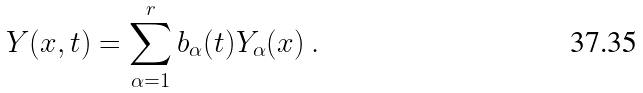Convert formula to latex. <formula><loc_0><loc_0><loc_500><loc_500>Y ( x , t ) = \sum _ { \alpha = 1 } ^ { r } b _ { \alpha } ( t ) Y _ { \alpha } ( x ) \ .</formula> 